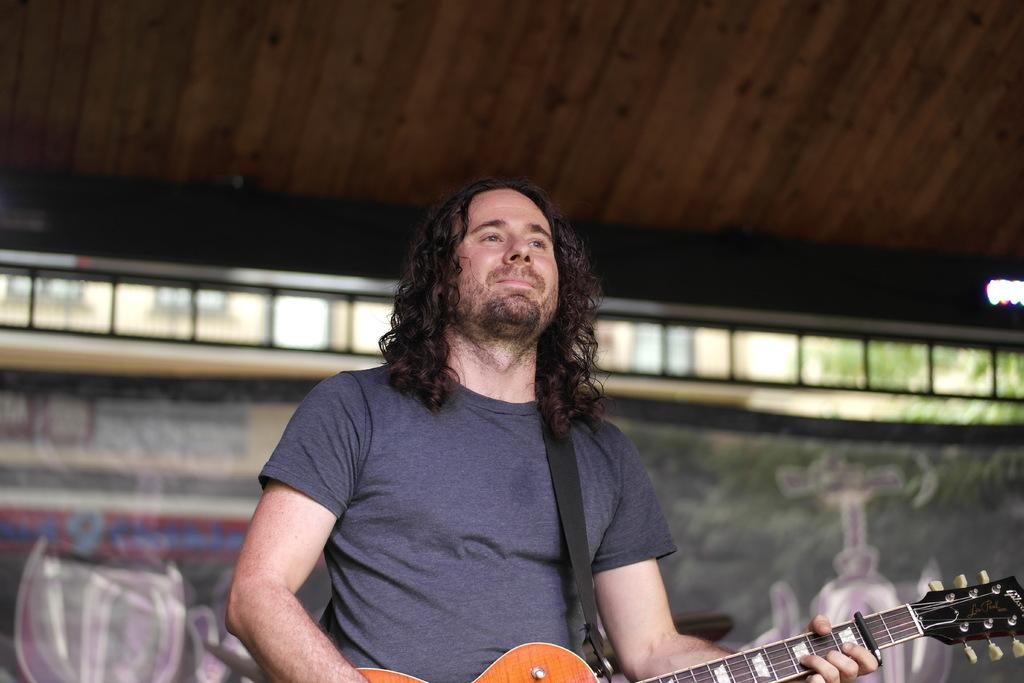What is the person in the image doing? The person is holding a guitar. What type of clothing is the person wearing? The person is wearing a t-shirt. Can you describe the color of the t-shirt? The t-shirt is in cement color. What type of silk material is used to make the match in the image? There is no match or silk material present in the image. 